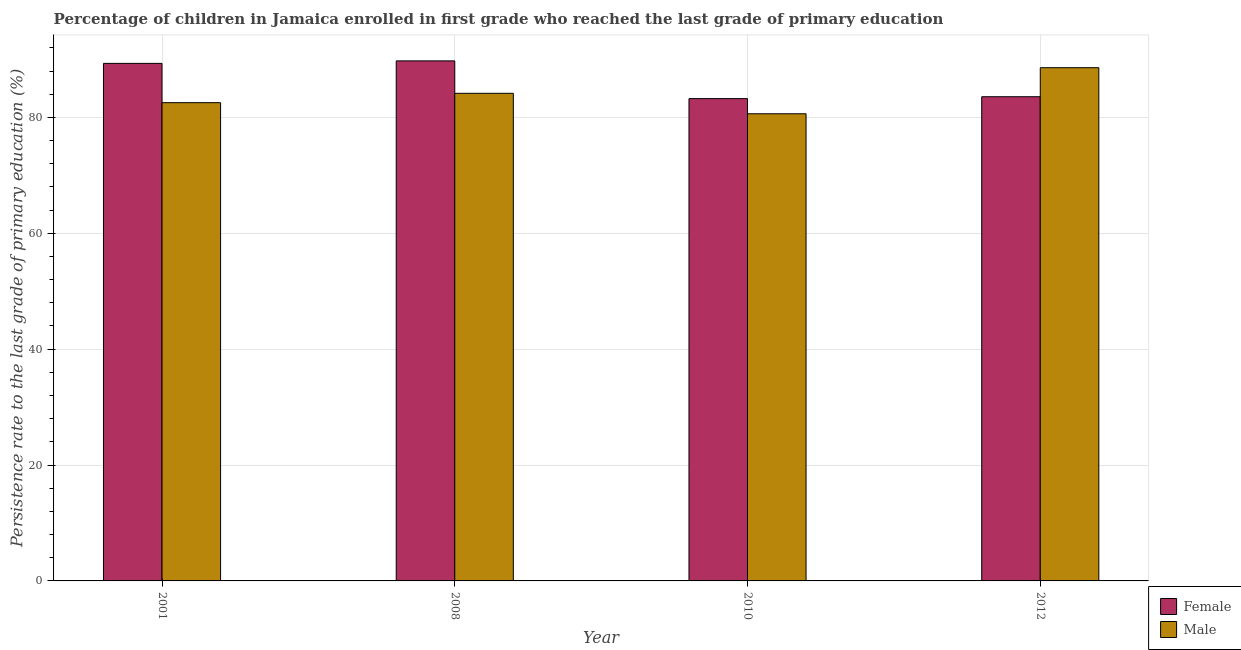Are the number of bars on each tick of the X-axis equal?
Provide a succinct answer. Yes. What is the label of the 1st group of bars from the left?
Keep it short and to the point. 2001. In how many cases, is the number of bars for a given year not equal to the number of legend labels?
Provide a short and direct response. 0. What is the persistence rate of male students in 2008?
Offer a terse response. 84.16. Across all years, what is the maximum persistence rate of male students?
Your response must be concise. 88.58. Across all years, what is the minimum persistence rate of female students?
Ensure brevity in your answer.  83.24. In which year was the persistence rate of male students maximum?
Make the answer very short. 2012. What is the total persistence rate of female students in the graph?
Make the answer very short. 345.9. What is the difference between the persistence rate of female students in 2008 and that in 2012?
Your response must be concise. 6.19. What is the difference between the persistence rate of female students in 2008 and the persistence rate of male students in 2010?
Your response must be concise. 6.51. What is the average persistence rate of male students per year?
Keep it short and to the point. 83.98. In how many years, is the persistence rate of female students greater than 56 %?
Keep it short and to the point. 4. What is the ratio of the persistence rate of male students in 2001 to that in 2010?
Offer a very short reply. 1.02. Is the difference between the persistence rate of male students in 2001 and 2012 greater than the difference between the persistence rate of female students in 2001 and 2012?
Offer a very short reply. No. What is the difference between the highest and the second highest persistence rate of female students?
Provide a succinct answer. 0.43. What is the difference between the highest and the lowest persistence rate of female students?
Your response must be concise. 6.51. What does the 1st bar from the left in 2008 represents?
Your answer should be compact. Female. What does the 2nd bar from the right in 2010 represents?
Make the answer very short. Female. How many bars are there?
Offer a terse response. 8. Are all the bars in the graph horizontal?
Provide a short and direct response. No. How many years are there in the graph?
Give a very brief answer. 4. What is the difference between two consecutive major ticks on the Y-axis?
Provide a short and direct response. 20. Does the graph contain any zero values?
Keep it short and to the point. No. Where does the legend appear in the graph?
Your answer should be compact. Bottom right. How are the legend labels stacked?
Make the answer very short. Vertical. What is the title of the graph?
Your response must be concise. Percentage of children in Jamaica enrolled in first grade who reached the last grade of primary education. What is the label or title of the Y-axis?
Ensure brevity in your answer.  Persistence rate to the last grade of primary education (%). What is the Persistence rate to the last grade of primary education (%) in Female in 2001?
Provide a succinct answer. 89.33. What is the Persistence rate to the last grade of primary education (%) in Male in 2001?
Your answer should be compact. 82.54. What is the Persistence rate to the last grade of primary education (%) in Female in 2008?
Give a very brief answer. 89.76. What is the Persistence rate to the last grade of primary education (%) in Male in 2008?
Give a very brief answer. 84.16. What is the Persistence rate to the last grade of primary education (%) of Female in 2010?
Provide a short and direct response. 83.24. What is the Persistence rate to the last grade of primary education (%) in Male in 2010?
Your response must be concise. 80.63. What is the Persistence rate to the last grade of primary education (%) in Female in 2012?
Your response must be concise. 83.57. What is the Persistence rate to the last grade of primary education (%) in Male in 2012?
Ensure brevity in your answer.  88.58. Across all years, what is the maximum Persistence rate to the last grade of primary education (%) of Female?
Your answer should be compact. 89.76. Across all years, what is the maximum Persistence rate to the last grade of primary education (%) of Male?
Your answer should be very brief. 88.58. Across all years, what is the minimum Persistence rate to the last grade of primary education (%) in Female?
Your response must be concise. 83.24. Across all years, what is the minimum Persistence rate to the last grade of primary education (%) of Male?
Provide a short and direct response. 80.63. What is the total Persistence rate to the last grade of primary education (%) of Female in the graph?
Your response must be concise. 345.9. What is the total Persistence rate to the last grade of primary education (%) in Male in the graph?
Provide a short and direct response. 335.92. What is the difference between the Persistence rate to the last grade of primary education (%) of Female in 2001 and that in 2008?
Your response must be concise. -0.43. What is the difference between the Persistence rate to the last grade of primary education (%) in Male in 2001 and that in 2008?
Ensure brevity in your answer.  -1.62. What is the difference between the Persistence rate to the last grade of primary education (%) in Female in 2001 and that in 2010?
Provide a succinct answer. 6.08. What is the difference between the Persistence rate to the last grade of primary education (%) of Male in 2001 and that in 2010?
Your response must be concise. 1.92. What is the difference between the Persistence rate to the last grade of primary education (%) of Female in 2001 and that in 2012?
Offer a terse response. 5.75. What is the difference between the Persistence rate to the last grade of primary education (%) of Male in 2001 and that in 2012?
Your answer should be compact. -6.04. What is the difference between the Persistence rate to the last grade of primary education (%) of Female in 2008 and that in 2010?
Offer a terse response. 6.51. What is the difference between the Persistence rate to the last grade of primary education (%) of Male in 2008 and that in 2010?
Offer a very short reply. 3.53. What is the difference between the Persistence rate to the last grade of primary education (%) in Female in 2008 and that in 2012?
Your response must be concise. 6.19. What is the difference between the Persistence rate to the last grade of primary education (%) in Male in 2008 and that in 2012?
Your response must be concise. -4.42. What is the difference between the Persistence rate to the last grade of primary education (%) in Female in 2010 and that in 2012?
Keep it short and to the point. -0.33. What is the difference between the Persistence rate to the last grade of primary education (%) in Male in 2010 and that in 2012?
Provide a short and direct response. -7.95. What is the difference between the Persistence rate to the last grade of primary education (%) in Female in 2001 and the Persistence rate to the last grade of primary education (%) in Male in 2008?
Make the answer very short. 5.17. What is the difference between the Persistence rate to the last grade of primary education (%) in Female in 2001 and the Persistence rate to the last grade of primary education (%) in Male in 2010?
Offer a very short reply. 8.7. What is the difference between the Persistence rate to the last grade of primary education (%) of Female in 2001 and the Persistence rate to the last grade of primary education (%) of Male in 2012?
Provide a short and direct response. 0.74. What is the difference between the Persistence rate to the last grade of primary education (%) of Female in 2008 and the Persistence rate to the last grade of primary education (%) of Male in 2010?
Your answer should be compact. 9.13. What is the difference between the Persistence rate to the last grade of primary education (%) in Female in 2008 and the Persistence rate to the last grade of primary education (%) in Male in 2012?
Your answer should be very brief. 1.18. What is the difference between the Persistence rate to the last grade of primary education (%) of Female in 2010 and the Persistence rate to the last grade of primary education (%) of Male in 2012?
Provide a short and direct response. -5.34. What is the average Persistence rate to the last grade of primary education (%) of Female per year?
Make the answer very short. 86.48. What is the average Persistence rate to the last grade of primary education (%) in Male per year?
Provide a succinct answer. 83.98. In the year 2001, what is the difference between the Persistence rate to the last grade of primary education (%) of Female and Persistence rate to the last grade of primary education (%) of Male?
Offer a terse response. 6.78. In the year 2008, what is the difference between the Persistence rate to the last grade of primary education (%) in Female and Persistence rate to the last grade of primary education (%) in Male?
Offer a terse response. 5.6. In the year 2010, what is the difference between the Persistence rate to the last grade of primary education (%) in Female and Persistence rate to the last grade of primary education (%) in Male?
Ensure brevity in your answer.  2.62. In the year 2012, what is the difference between the Persistence rate to the last grade of primary education (%) of Female and Persistence rate to the last grade of primary education (%) of Male?
Make the answer very short. -5.01. What is the ratio of the Persistence rate to the last grade of primary education (%) in Male in 2001 to that in 2008?
Offer a terse response. 0.98. What is the ratio of the Persistence rate to the last grade of primary education (%) in Female in 2001 to that in 2010?
Give a very brief answer. 1.07. What is the ratio of the Persistence rate to the last grade of primary education (%) in Male in 2001 to that in 2010?
Ensure brevity in your answer.  1.02. What is the ratio of the Persistence rate to the last grade of primary education (%) of Female in 2001 to that in 2012?
Make the answer very short. 1.07. What is the ratio of the Persistence rate to the last grade of primary education (%) of Male in 2001 to that in 2012?
Make the answer very short. 0.93. What is the ratio of the Persistence rate to the last grade of primary education (%) in Female in 2008 to that in 2010?
Ensure brevity in your answer.  1.08. What is the ratio of the Persistence rate to the last grade of primary education (%) of Male in 2008 to that in 2010?
Your answer should be very brief. 1.04. What is the ratio of the Persistence rate to the last grade of primary education (%) of Female in 2008 to that in 2012?
Offer a terse response. 1.07. What is the ratio of the Persistence rate to the last grade of primary education (%) of Male in 2008 to that in 2012?
Ensure brevity in your answer.  0.95. What is the ratio of the Persistence rate to the last grade of primary education (%) of Male in 2010 to that in 2012?
Offer a terse response. 0.91. What is the difference between the highest and the second highest Persistence rate to the last grade of primary education (%) of Female?
Your response must be concise. 0.43. What is the difference between the highest and the second highest Persistence rate to the last grade of primary education (%) in Male?
Offer a very short reply. 4.42. What is the difference between the highest and the lowest Persistence rate to the last grade of primary education (%) in Female?
Your response must be concise. 6.51. What is the difference between the highest and the lowest Persistence rate to the last grade of primary education (%) of Male?
Offer a very short reply. 7.95. 